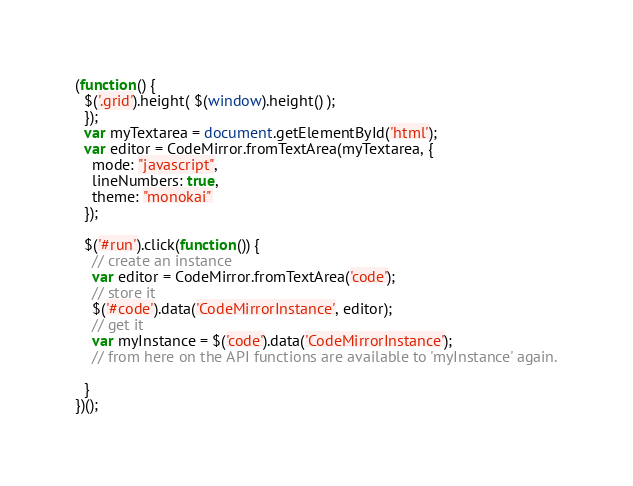Convert code to text. <code><loc_0><loc_0><loc_500><loc_500><_JavaScript_>(function() {
  $('.grid').height( $(window).height() );
  });
  var myTextarea = document.getElementById('html');
  var editor = CodeMirror.fromTextArea(myTextarea, {
    mode: "javascript",
    lineNumbers: true,
    theme: "monokai"
  });

  $('#run').click(function()) {
    // create an instance
    var editor = CodeMirror.fromTextArea('code');
    // store it
    $('#code').data('CodeMirrorInstance', editor);
    // get it
    var myInstance = $('code').data('CodeMirrorInstance');
    // from here on the API functions are available to 'myInstance' again.

  }
})();
</code> 